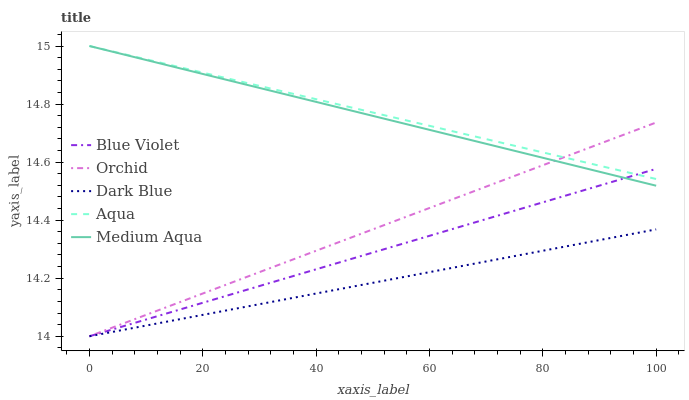Does Dark Blue have the minimum area under the curve?
Answer yes or no. Yes. Does Aqua have the maximum area under the curve?
Answer yes or no. Yes. Does Aqua have the minimum area under the curve?
Answer yes or no. No. Does Dark Blue have the maximum area under the curve?
Answer yes or no. No. Is Dark Blue the smoothest?
Answer yes or no. Yes. Is Blue Violet the roughest?
Answer yes or no. Yes. Is Aqua the smoothest?
Answer yes or no. No. Is Aqua the roughest?
Answer yes or no. No. Does Dark Blue have the lowest value?
Answer yes or no. Yes. Does Aqua have the lowest value?
Answer yes or no. No. Does Aqua have the highest value?
Answer yes or no. Yes. Does Dark Blue have the highest value?
Answer yes or no. No. Is Dark Blue less than Aqua?
Answer yes or no. Yes. Is Aqua greater than Dark Blue?
Answer yes or no. Yes. Does Aqua intersect Orchid?
Answer yes or no. Yes. Is Aqua less than Orchid?
Answer yes or no. No. Is Aqua greater than Orchid?
Answer yes or no. No. Does Dark Blue intersect Aqua?
Answer yes or no. No. 